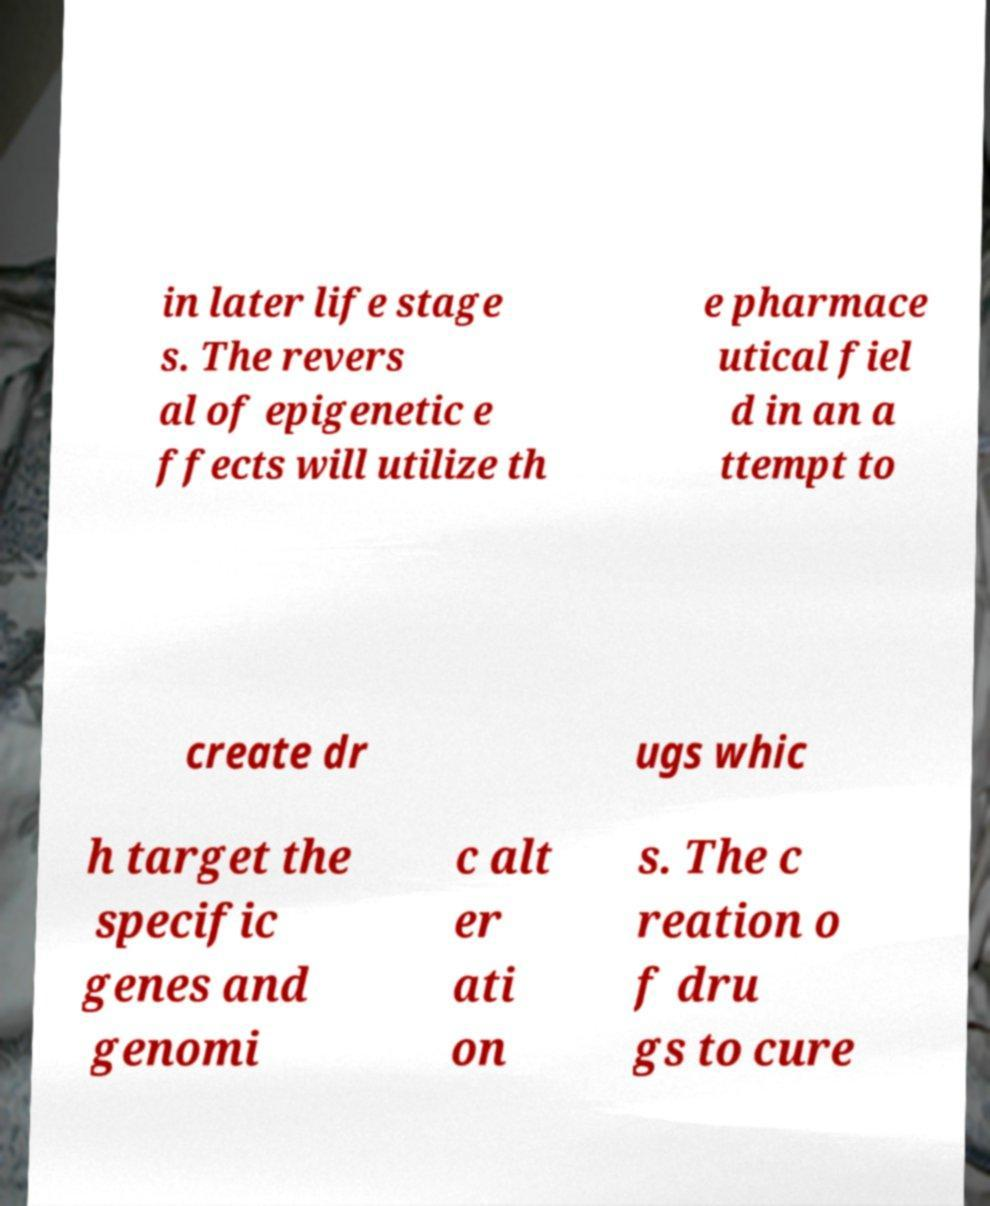Please identify and transcribe the text found in this image. in later life stage s. The revers al of epigenetic e ffects will utilize th e pharmace utical fiel d in an a ttempt to create dr ugs whic h target the specific genes and genomi c alt er ati on s. The c reation o f dru gs to cure 